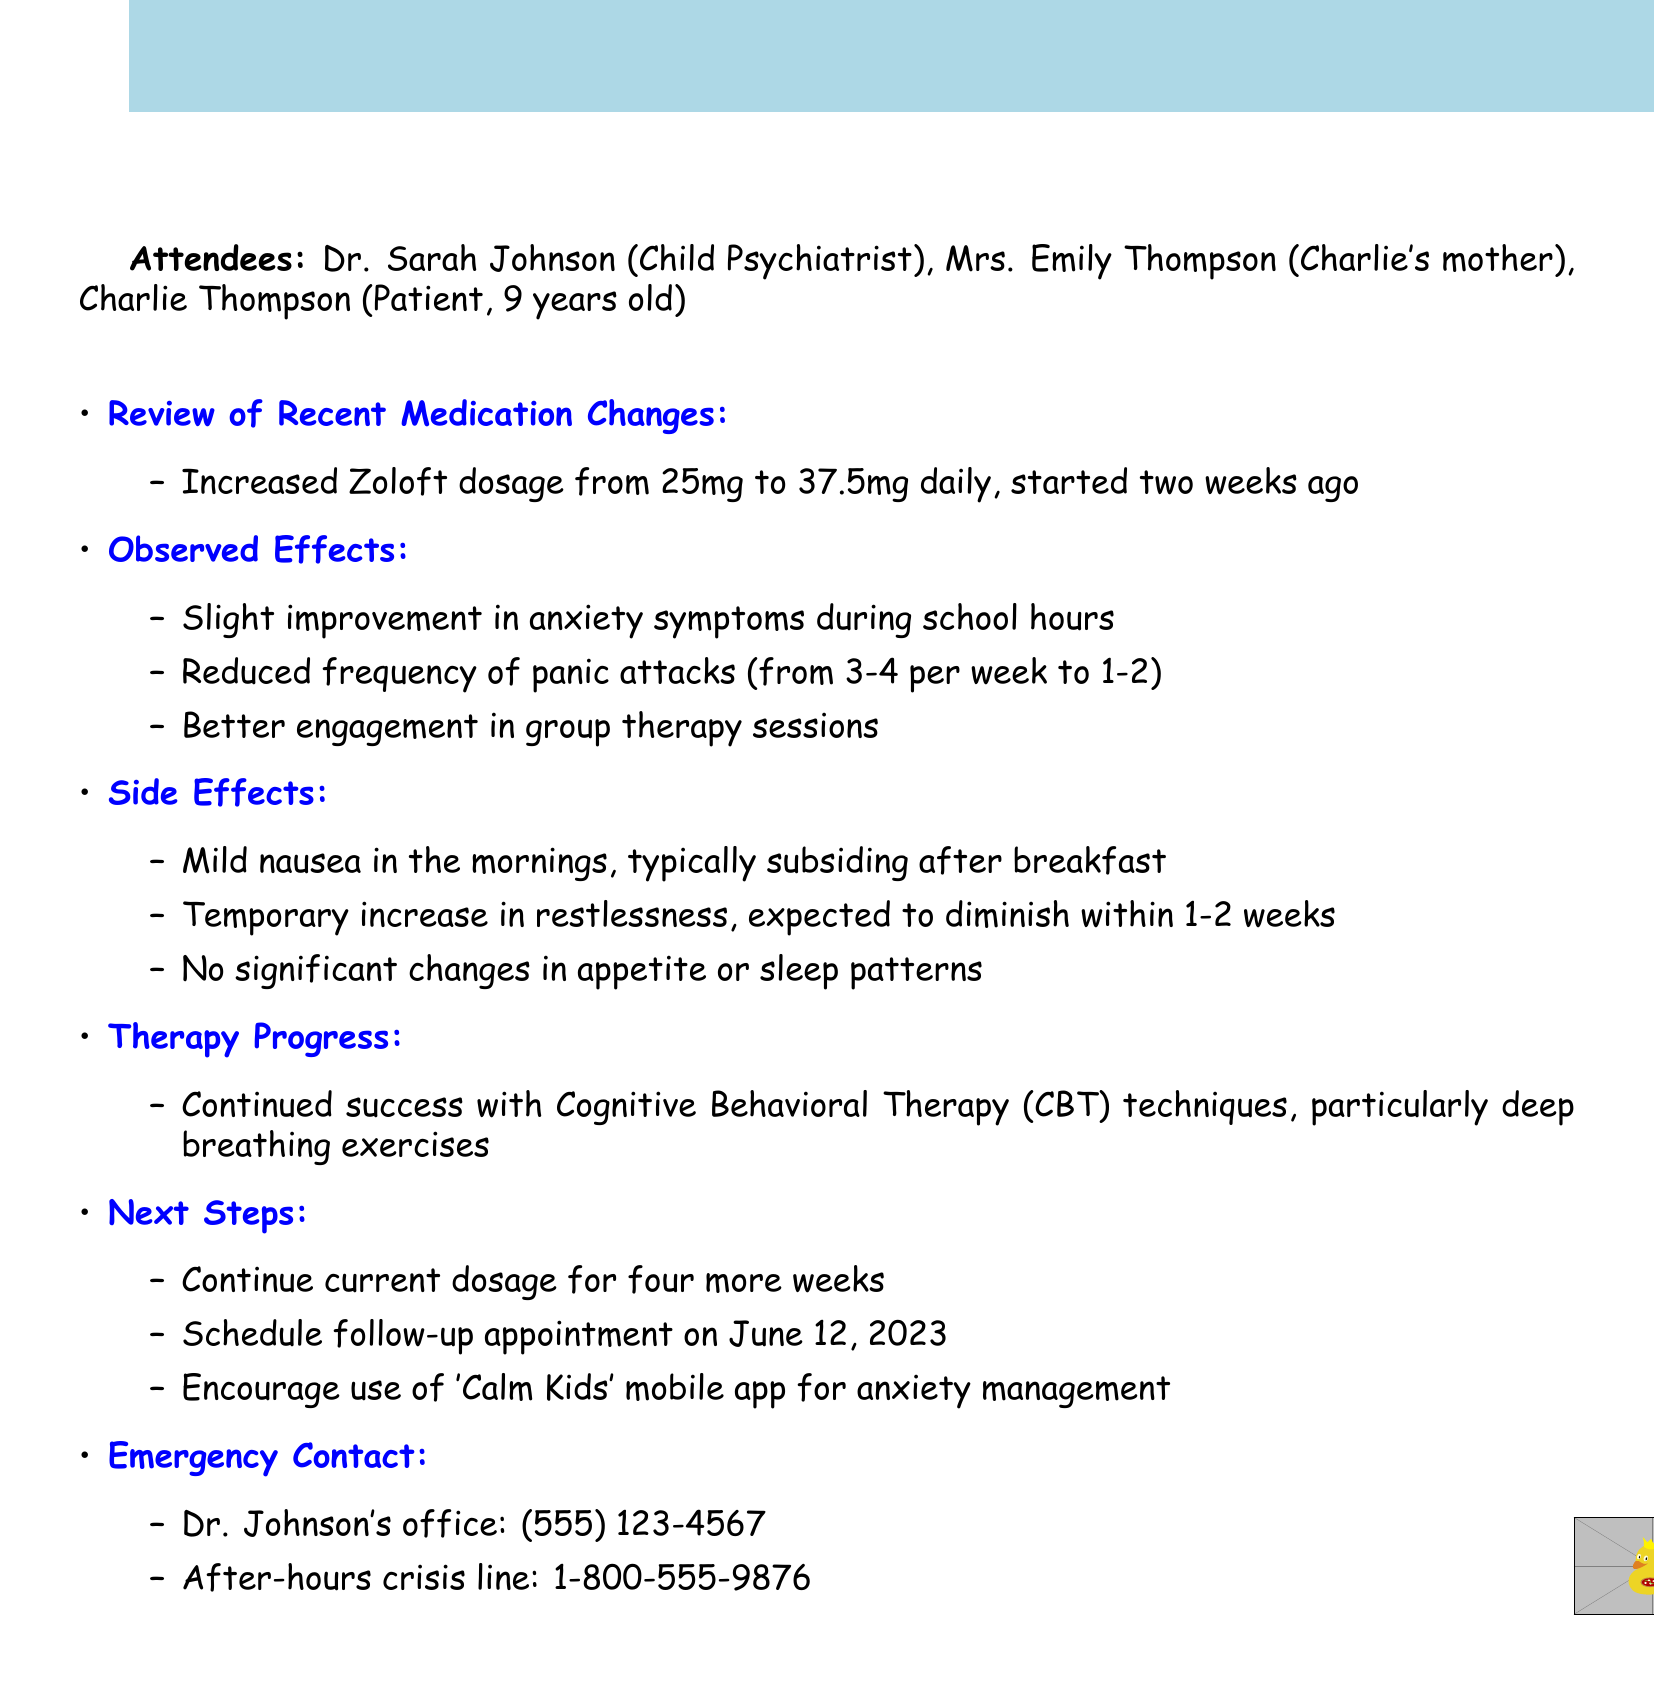what was the increase in Zoloft dosage? The dosage was increased from 25mg to 37.5mg daily.
Answer: from 25mg to 37.5mg who attended the meeting? The document lists the attendees as Dr. Sarah Johnson, Mrs. Emily Thompson, and Charlie Thompson.
Answer: Dr. Sarah Johnson, Mrs. Emily Thompson, Charlie Thompson what is the date of the follow-up appointment? The follow-up appointment is scheduled four weeks later, on June 12, 2023.
Answer: June 12, 2023 how many panic attacks did Charlie experience per week after medication adjustment? The frequency of panic attacks was reduced from 3-4 per week to 1-2 per week.
Answer: 1-2 what side effect was noted in the mornings? Mild nausea was observed in the mornings.
Answer: Mild nausea what therapy technique is mentioned in the document? The meeting notes mention the continued success with Cognitive Behavioral Therapy (CBT) techniques.
Answer: Cognitive Behavioral Therapy (CBT) how long is the expected duration for the temporary increase in restlessness? The restlessness is expected to diminish within 1-2 weeks.
Answer: 1-2 weeks 